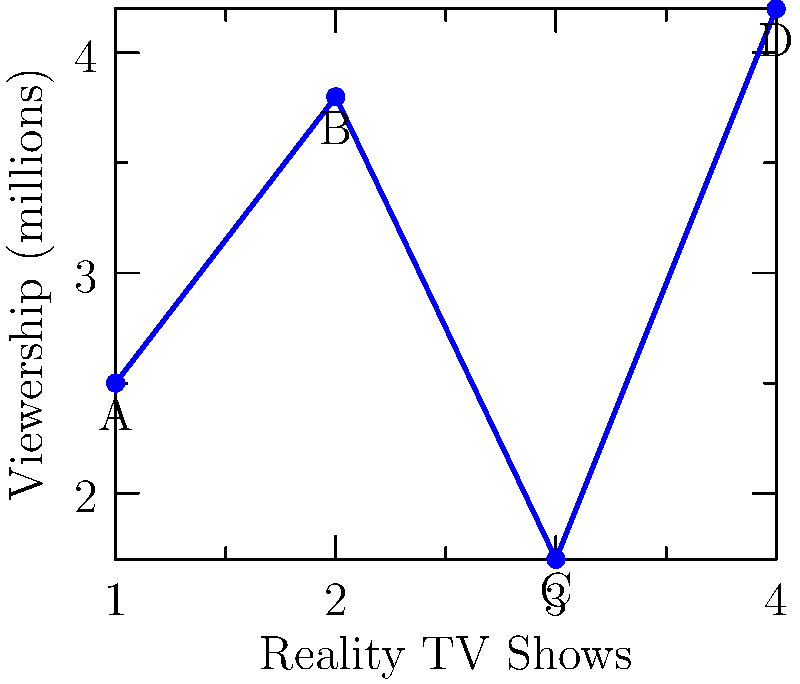The graph shows the viewership (in millions) for four popular reality TV shows in Bangladesh. If you were to calculate the total viewership using vector addition, what would be the magnitude of the resulting vector? Round your answer to one decimal place. To solve this problem, we'll treat each show's viewership as a component of a vector and use vector addition to find the total viewership. Here's the step-by-step process:

1. Identify the viewership for each show:
   Show A: 2.5 million
   Show B: 3.8 million
   Show C: 1.7 million
   Show D: 4.2 million

2. Set up the vector addition:
   $\vec{v} = (2.5, 3.8, 1.7, 4.2)$

3. To find the magnitude of the resulting vector, we use the formula:
   $|\vec{v}| = \sqrt{v_1^2 + v_2^2 + v_3^2 + v_4^2}$

4. Substitute the values:
   $|\vec{v}| = \sqrt{2.5^2 + 3.8^2 + 1.7^2 + 4.2^2}$

5. Calculate:
   $|\vec{v}| = \sqrt{6.25 + 14.44 + 2.89 + 17.64}$
   $|\vec{v}| = \sqrt{41.22}$
   $|\vec{v}| \approx 6.42$ million

6. Round to one decimal place:
   $|\vec{v}| \approx 6.4$ million

Therefore, the magnitude of the resulting vector, representing the total viewership, is approximately 6.4 million.
Answer: 6.4 million 